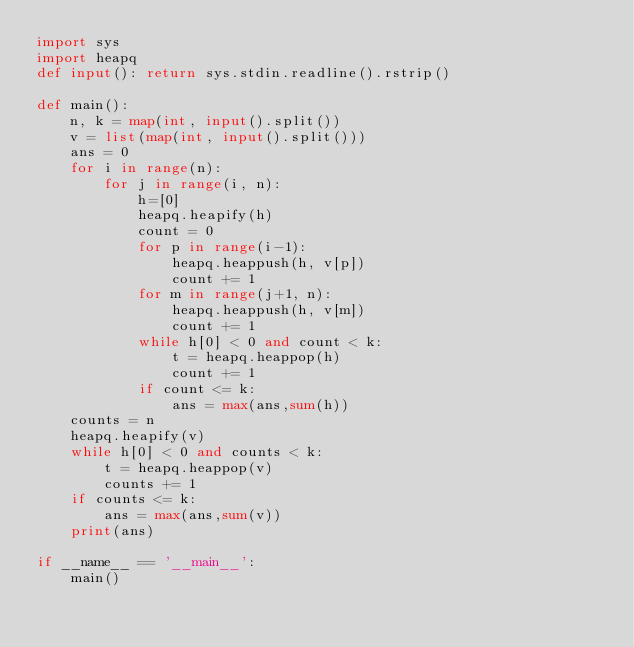Convert code to text. <code><loc_0><loc_0><loc_500><loc_500><_Python_>import sys
import heapq
def input(): return sys.stdin.readline().rstrip()

def main():
    n, k = map(int, input().split())
    v = list(map(int, input().split()))
    ans = 0
    for i in range(n):
        for j in range(i, n):
            h=[0]
            heapq.heapify(h)
            count = 0
            for p in range(i-1):
                heapq.heappush(h, v[p])
                count += 1
            for m in range(j+1, n):
                heapq.heappush(h, v[m])
                count += 1
            while h[0] < 0 and count < k:
                t = heapq.heappop(h)
                count += 1
            if count <= k:
                ans = max(ans,sum(h))
    counts = n
    heapq.heapify(v)
    while h[0] < 0 and counts < k:
        t = heapq.heappop(v)
        counts += 1
    if counts <= k:
        ans = max(ans,sum(v))
    print(ans)
   
if __name__ == '__main__':
    main()</code> 